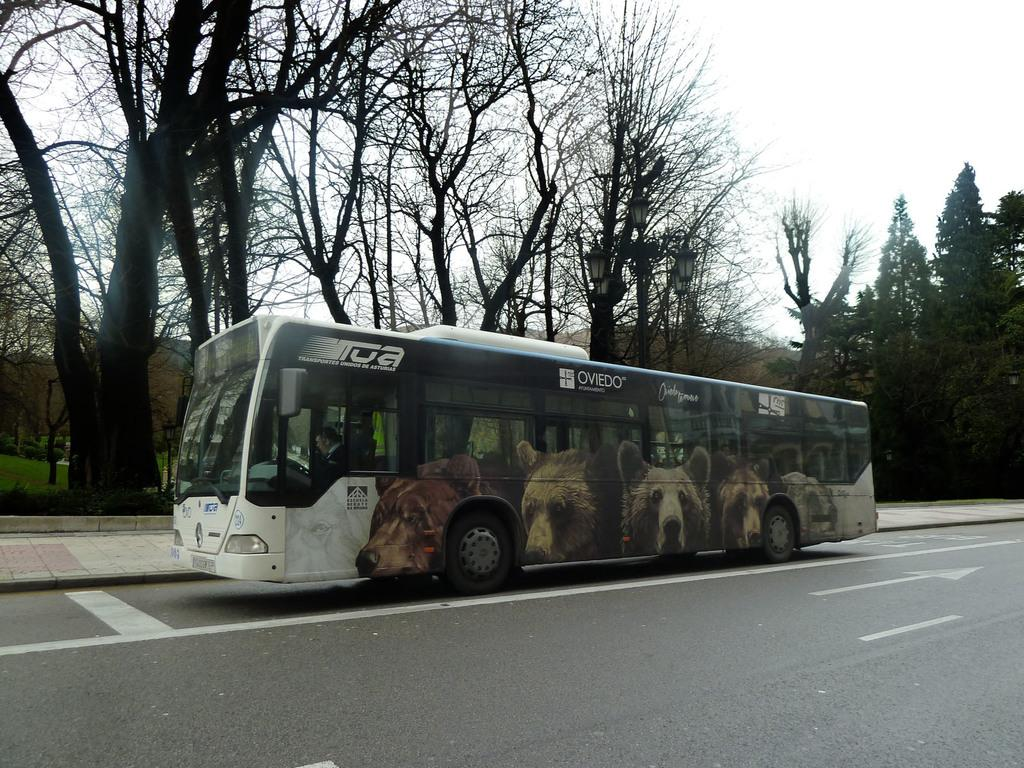What is happening in the image? There is a vehicle moving on the road in the image. What can be seen in the background of the image? Trees and grass are visible in the image. What type of cap is the zebra wearing in the image? There is no zebra or cap present in the image. 